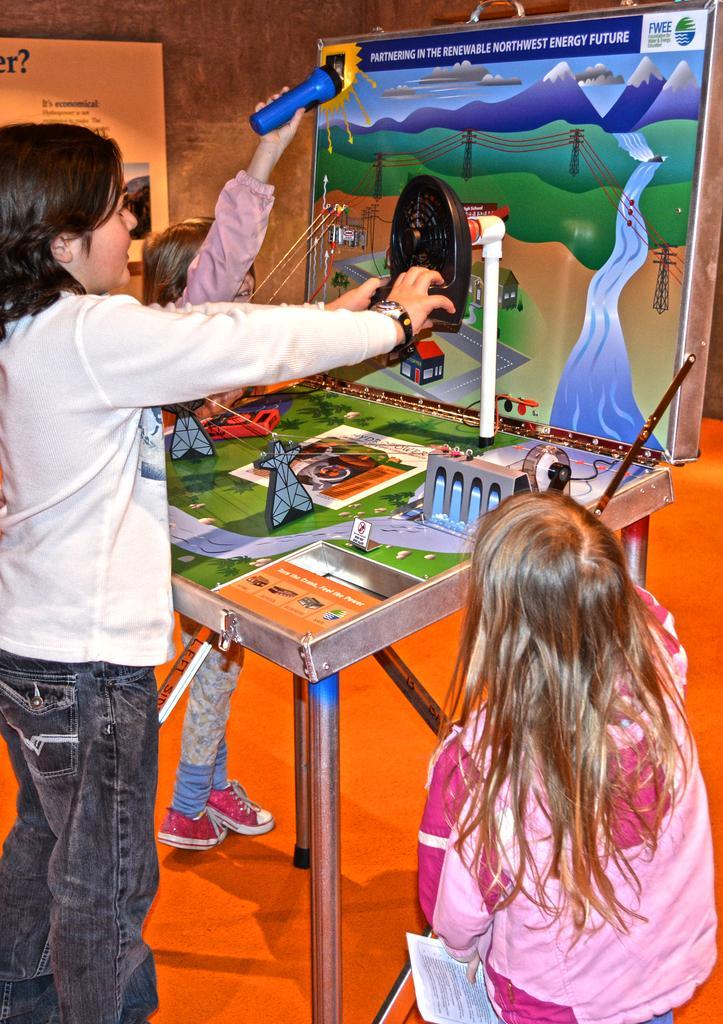Can you describe this image briefly? In this picture we can see three persons standing on the floor. This is table and they are playing game. On the background we can see a frame on the wall. And this is floor. 